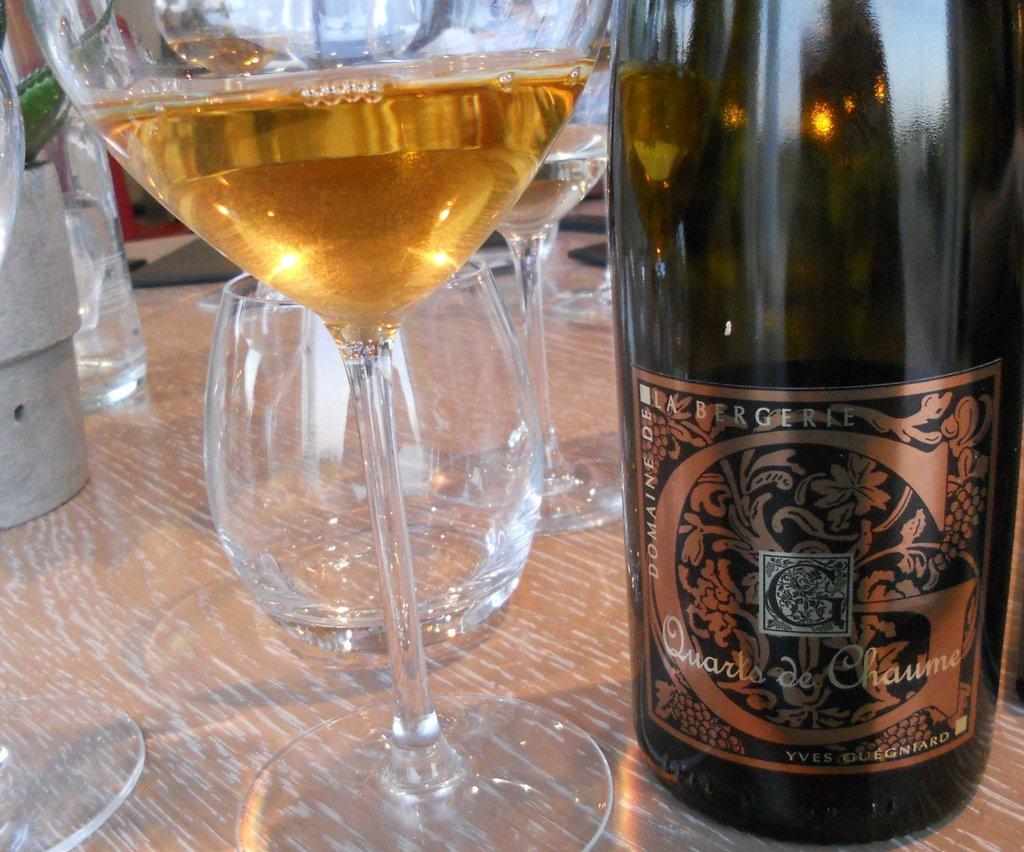<image>
Render a clear and concise summary of the photo. a DOMAINE DE LA BERGERIE Quarts de Chaume liquor bottle and a glass of it next to. 